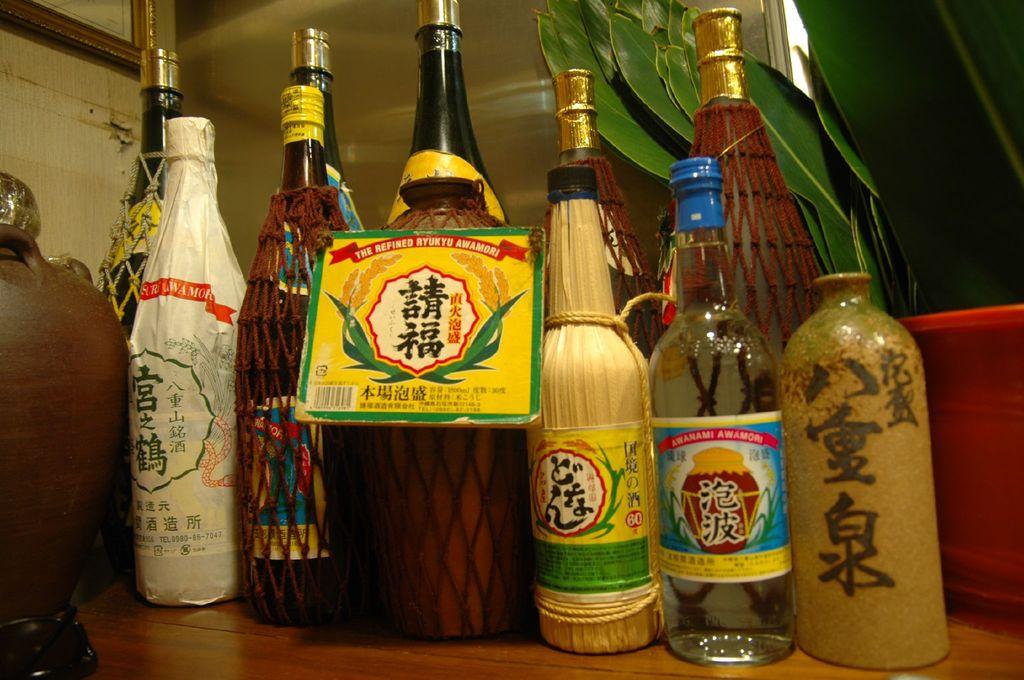What number is shown in white text on a red background on the bottle with the green and yellow label?
Your response must be concise. 60. 